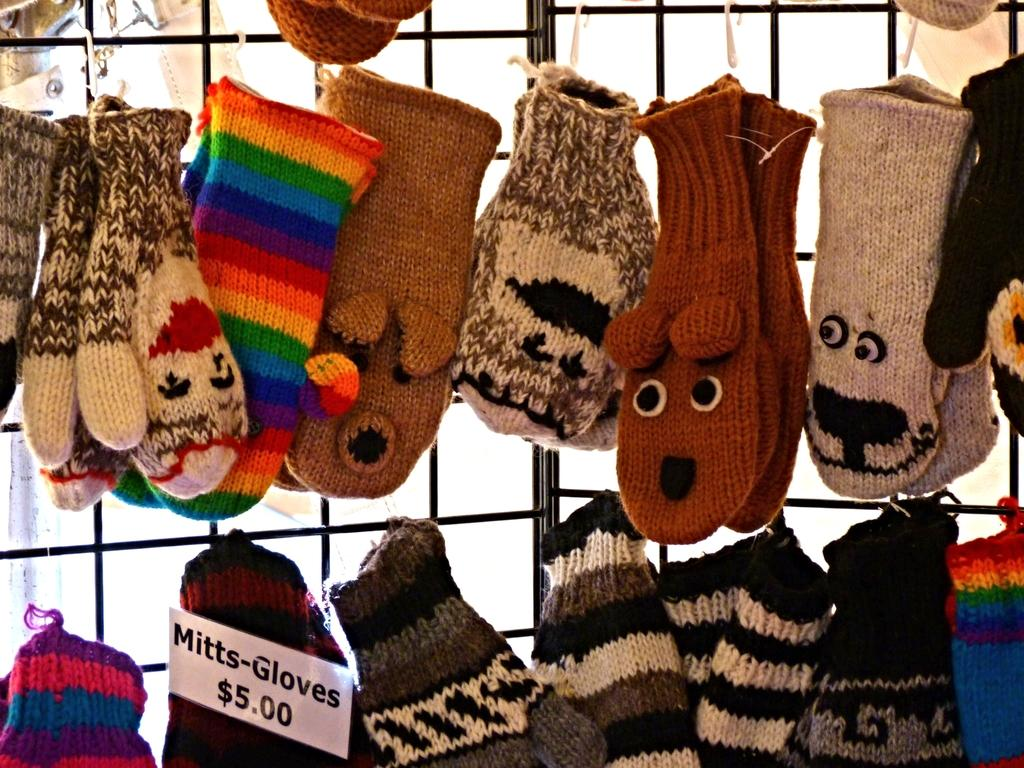What is the main subject of the image? The main subject of the image is many loaves. Can you describe the appearance of the loaves? The loaves are in multicolor. What else can be seen in the image besides the loaves? There are gloves hanging on a railing in the image. How many pizzas are stacked on top of each other in the image? There are no pizzas present in the image; it features loaves of bread. What shape are the loaves in the image? The provided facts do not mention the shape of the loaves, only their colors. 